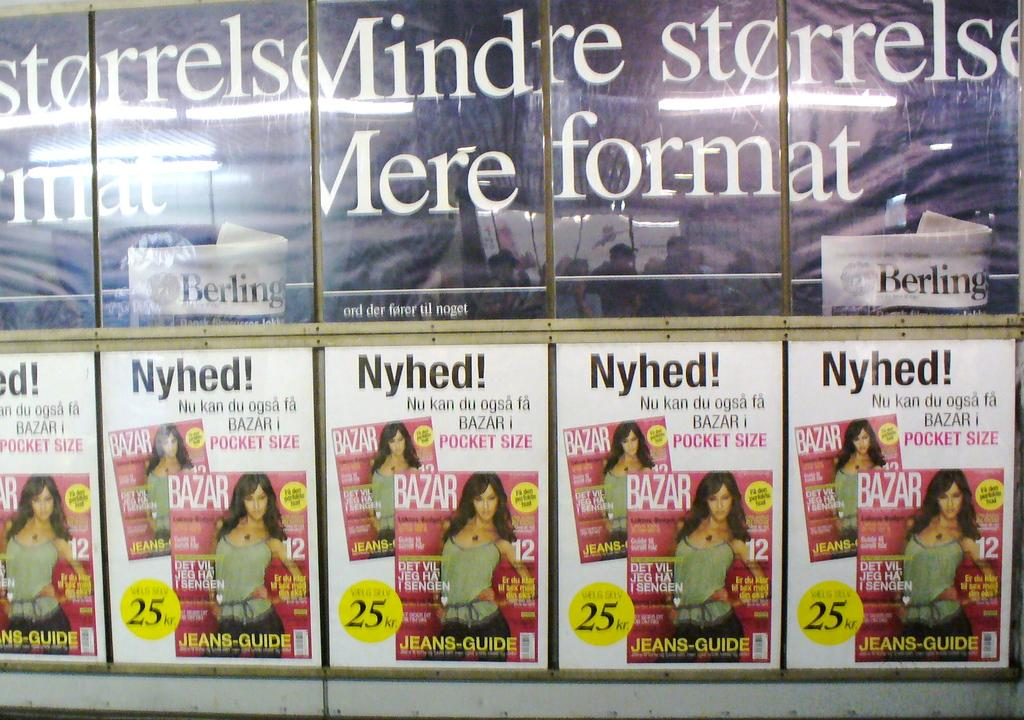Provide a one-sentence caption for the provided image. A woman is on the cover of multiple flyers and the words are in a foreign language. 